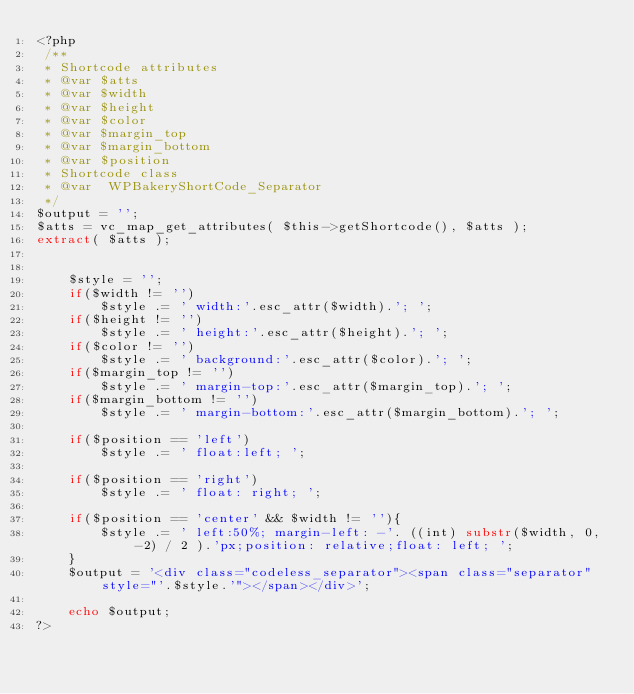<code> <loc_0><loc_0><loc_500><loc_500><_PHP_><?php
 /**
 * Shortcode attributes
 * @var $atts
 * @var $width
 * @var $height
 * @var $color
 * @var $margin_top
 * @var $margin_bottom
 * @var $position
 * Shortcode class
 * @var  WPBakeryShortCode_Separator
 */
$output = '';
$atts = vc_map_get_attributes( $this->getShortcode(), $atts );
extract( $atts );


    $style = '';
    if($width != '')
        $style .= ' width:'.esc_attr($width).'; ';
    if($height != '')
        $style .= ' height:'.esc_attr($height).'; ';
    if($color != '')
        $style .= ' background:'.esc_attr($color).'; ';
    if($margin_top != '')
        $style .= ' margin-top:'.esc_attr($margin_top).'; ';
    if($margin_bottom != '')
        $style .= ' margin-bottom:'.esc_attr($margin_bottom).'; ';

    if($position == 'left') 
        $style .= ' float:left; ';

    if($position == 'right')
        $style .= ' float: right; ';

    if($position == 'center' && $width != ''){
        $style .= ' left:50%; margin-left: -'. ((int) substr($width, 0, -2) / 2 ).'px;position: relative;float: left; ';
    }
    $output = '<div class="codeless_separator"><span class="separator" style="'.$style.'"></span></div>';

    echo $output;
?></code> 